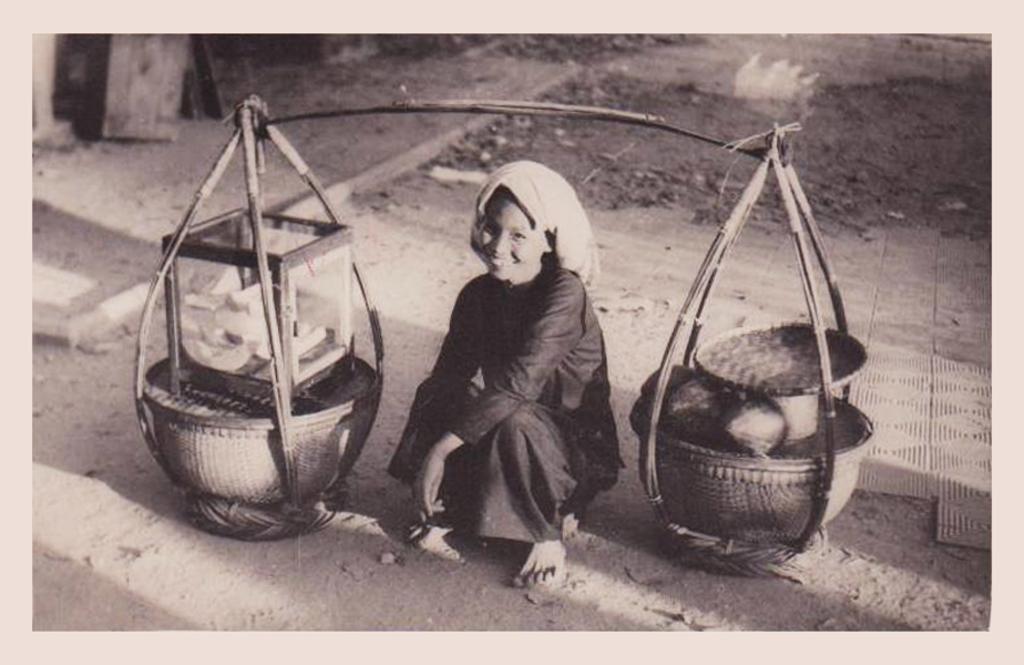Could you give a brief overview of what you see in this image? In this image I can see a person is sitting. I can see the carrying pole and few object in it. The image is black and white. 